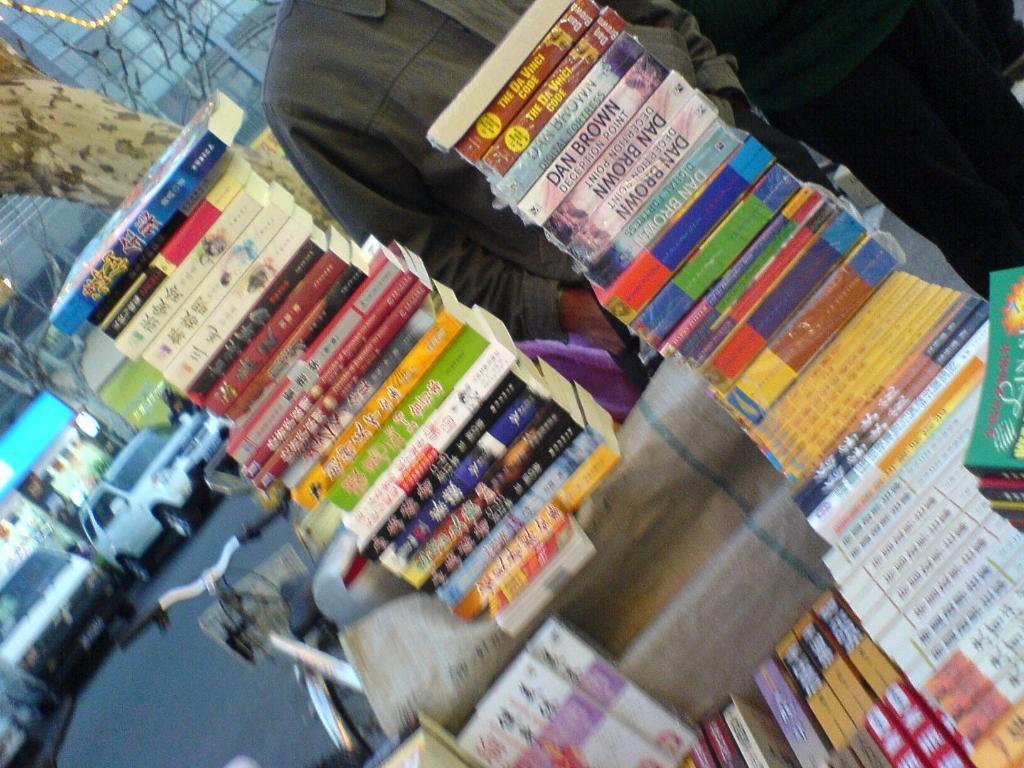<image>
Provide a brief description of the given image. A stack of books sits next to a bicycle and includes several by Dan Brown, including The Da Vinci Code. 